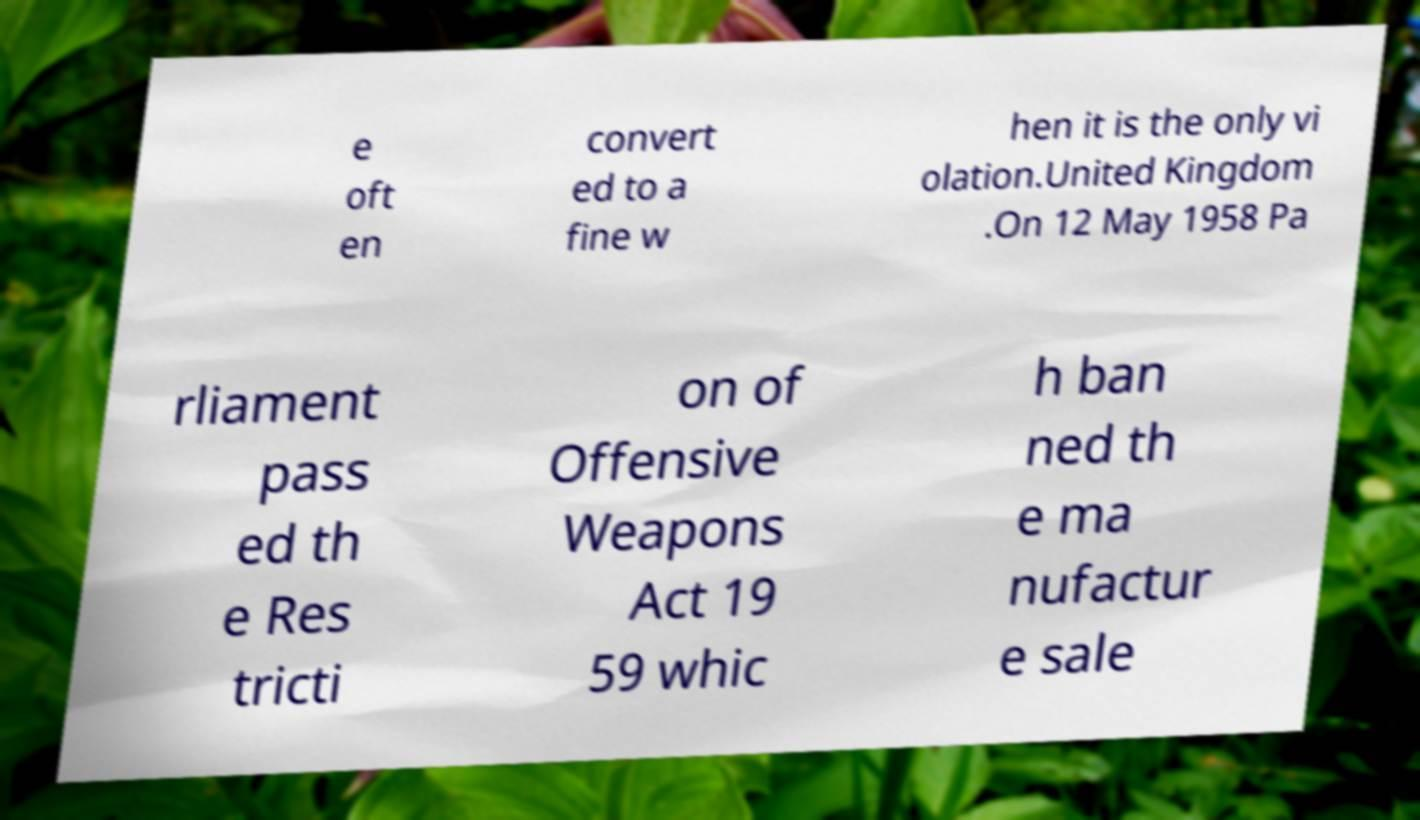I need the written content from this picture converted into text. Can you do that? e oft en convert ed to a fine w hen it is the only vi olation.United Kingdom .On 12 May 1958 Pa rliament pass ed th e Res tricti on of Offensive Weapons Act 19 59 whic h ban ned th e ma nufactur e sale 